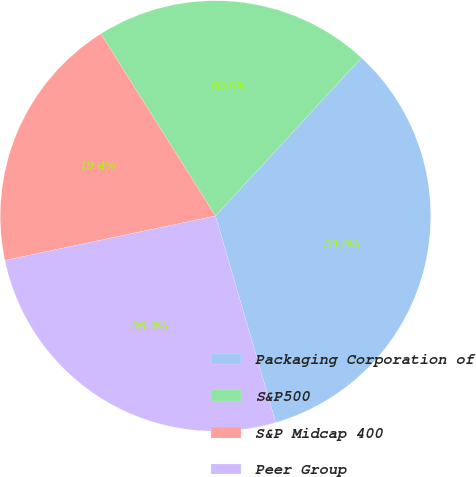Convert chart. <chart><loc_0><loc_0><loc_500><loc_500><pie_chart><fcel>Packaging Corporation of<fcel>S&P500<fcel>S&P Midcap 400<fcel>Peer Group<nl><fcel>33.62%<fcel>20.8%<fcel>19.37%<fcel>26.21%<nl></chart> 